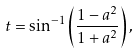Convert formula to latex. <formula><loc_0><loc_0><loc_500><loc_500>t = \sin ^ { - 1 } \left ( \frac { 1 - a ^ { 2 } } { 1 + a ^ { 2 } } \right ) ,</formula> 